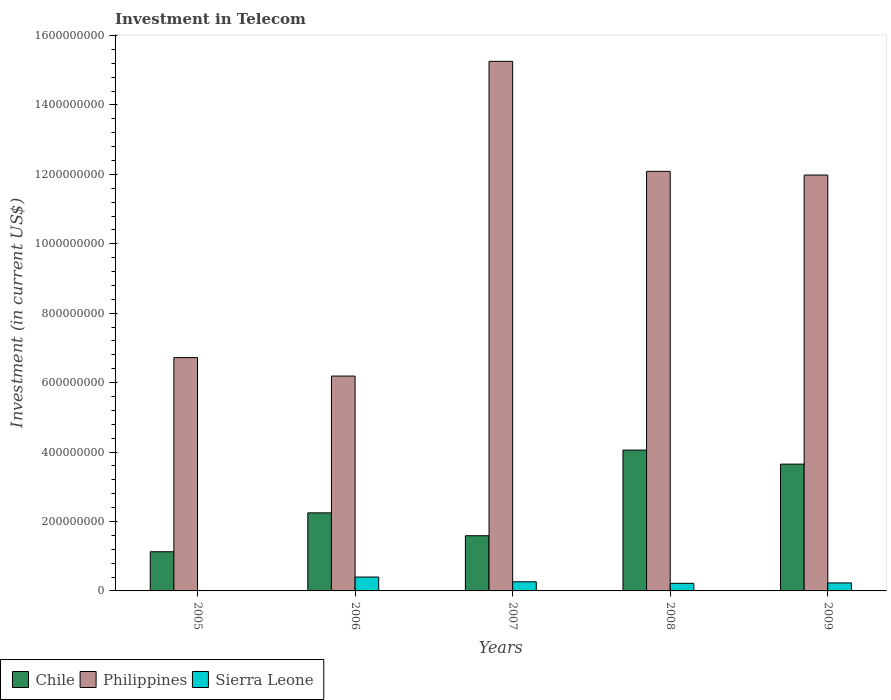Are the number of bars on each tick of the X-axis equal?
Your answer should be very brief. Yes. How many bars are there on the 5th tick from the right?
Offer a very short reply. 3. In how many cases, is the number of bars for a given year not equal to the number of legend labels?
Give a very brief answer. 0. What is the amount invested in telecom in Chile in 2006?
Make the answer very short. 2.25e+08. Across all years, what is the maximum amount invested in telecom in Sierra Leone?
Give a very brief answer. 4.00e+07. Across all years, what is the minimum amount invested in telecom in Chile?
Your answer should be very brief. 1.13e+08. In which year was the amount invested in telecom in Philippines maximum?
Make the answer very short. 2007. What is the total amount invested in telecom in Sierra Leone in the graph?
Offer a terse response. 1.11e+08. What is the difference between the amount invested in telecom in Sierra Leone in 2006 and that in 2007?
Provide a succinct answer. 1.37e+07. What is the difference between the amount invested in telecom in Sierra Leone in 2005 and the amount invested in telecom in Chile in 2006?
Your answer should be very brief. -2.25e+08. What is the average amount invested in telecom in Chile per year?
Your answer should be compact. 2.54e+08. In the year 2007, what is the difference between the amount invested in telecom in Philippines and amount invested in telecom in Chile?
Your answer should be compact. 1.37e+09. In how many years, is the amount invested in telecom in Chile greater than 1560000000 US$?
Ensure brevity in your answer.  0. What is the ratio of the amount invested in telecom in Chile in 2006 to that in 2008?
Offer a very short reply. 0.55. What is the difference between the highest and the second highest amount invested in telecom in Chile?
Your answer should be compact. 4.04e+07. What is the difference between the highest and the lowest amount invested in telecom in Sierra Leone?
Ensure brevity in your answer.  3.98e+07. In how many years, is the amount invested in telecom in Philippines greater than the average amount invested in telecom in Philippines taken over all years?
Your answer should be compact. 3. Is the sum of the amount invested in telecom in Chile in 2006 and 2007 greater than the maximum amount invested in telecom in Sierra Leone across all years?
Make the answer very short. Yes. What does the 3rd bar from the left in 2009 represents?
Your response must be concise. Sierra Leone. What does the 2nd bar from the right in 2007 represents?
Offer a terse response. Philippines. How many years are there in the graph?
Make the answer very short. 5. What is the difference between two consecutive major ticks on the Y-axis?
Your response must be concise. 2.00e+08. Are the values on the major ticks of Y-axis written in scientific E-notation?
Your response must be concise. No. Does the graph contain any zero values?
Keep it short and to the point. No. Does the graph contain grids?
Provide a short and direct response. No. Where does the legend appear in the graph?
Provide a succinct answer. Bottom left. How are the legend labels stacked?
Give a very brief answer. Horizontal. What is the title of the graph?
Your answer should be very brief. Investment in Telecom. Does "Zimbabwe" appear as one of the legend labels in the graph?
Make the answer very short. No. What is the label or title of the X-axis?
Make the answer very short. Years. What is the label or title of the Y-axis?
Keep it short and to the point. Investment (in current US$). What is the Investment (in current US$) in Chile in 2005?
Keep it short and to the point. 1.13e+08. What is the Investment (in current US$) in Philippines in 2005?
Offer a terse response. 6.72e+08. What is the Investment (in current US$) of Sierra Leone in 2005?
Offer a very short reply. 2.50e+05. What is the Investment (in current US$) of Chile in 2006?
Give a very brief answer. 2.25e+08. What is the Investment (in current US$) of Philippines in 2006?
Offer a very short reply. 6.19e+08. What is the Investment (in current US$) in Sierra Leone in 2006?
Keep it short and to the point. 4.00e+07. What is the Investment (in current US$) in Chile in 2007?
Offer a very short reply. 1.59e+08. What is the Investment (in current US$) of Philippines in 2007?
Keep it short and to the point. 1.53e+09. What is the Investment (in current US$) in Sierra Leone in 2007?
Your response must be concise. 2.63e+07. What is the Investment (in current US$) in Chile in 2008?
Your answer should be compact. 4.06e+08. What is the Investment (in current US$) of Philippines in 2008?
Your answer should be compact. 1.21e+09. What is the Investment (in current US$) in Sierra Leone in 2008?
Offer a very short reply. 2.19e+07. What is the Investment (in current US$) of Chile in 2009?
Keep it short and to the point. 3.65e+08. What is the Investment (in current US$) of Philippines in 2009?
Provide a succinct answer. 1.20e+09. What is the Investment (in current US$) in Sierra Leone in 2009?
Offer a very short reply. 2.30e+07. Across all years, what is the maximum Investment (in current US$) in Chile?
Ensure brevity in your answer.  4.06e+08. Across all years, what is the maximum Investment (in current US$) in Philippines?
Offer a very short reply. 1.53e+09. Across all years, what is the maximum Investment (in current US$) in Sierra Leone?
Offer a terse response. 4.00e+07. Across all years, what is the minimum Investment (in current US$) in Chile?
Ensure brevity in your answer.  1.13e+08. Across all years, what is the minimum Investment (in current US$) of Philippines?
Ensure brevity in your answer.  6.19e+08. What is the total Investment (in current US$) of Chile in the graph?
Give a very brief answer. 1.27e+09. What is the total Investment (in current US$) in Philippines in the graph?
Give a very brief answer. 5.22e+09. What is the total Investment (in current US$) of Sierra Leone in the graph?
Offer a terse response. 1.11e+08. What is the difference between the Investment (in current US$) of Chile in 2005 and that in 2006?
Your answer should be compact. -1.12e+08. What is the difference between the Investment (in current US$) in Philippines in 2005 and that in 2006?
Provide a short and direct response. 5.32e+07. What is the difference between the Investment (in current US$) in Sierra Leone in 2005 and that in 2006?
Make the answer very short. -3.98e+07. What is the difference between the Investment (in current US$) of Chile in 2005 and that in 2007?
Your answer should be compact. -4.61e+07. What is the difference between the Investment (in current US$) in Philippines in 2005 and that in 2007?
Your answer should be very brief. -8.53e+08. What is the difference between the Investment (in current US$) of Sierra Leone in 2005 and that in 2007?
Offer a very short reply. -2.60e+07. What is the difference between the Investment (in current US$) in Chile in 2005 and that in 2008?
Your answer should be very brief. -2.93e+08. What is the difference between the Investment (in current US$) of Philippines in 2005 and that in 2008?
Your response must be concise. -5.36e+08. What is the difference between the Investment (in current US$) of Sierra Leone in 2005 and that in 2008?
Offer a very short reply. -2.16e+07. What is the difference between the Investment (in current US$) of Chile in 2005 and that in 2009?
Provide a short and direct response. -2.52e+08. What is the difference between the Investment (in current US$) in Philippines in 2005 and that in 2009?
Make the answer very short. -5.26e+08. What is the difference between the Investment (in current US$) in Sierra Leone in 2005 and that in 2009?
Provide a succinct answer. -2.28e+07. What is the difference between the Investment (in current US$) of Chile in 2006 and that in 2007?
Your answer should be compact. 6.59e+07. What is the difference between the Investment (in current US$) in Philippines in 2006 and that in 2007?
Provide a succinct answer. -9.07e+08. What is the difference between the Investment (in current US$) in Sierra Leone in 2006 and that in 2007?
Your response must be concise. 1.37e+07. What is the difference between the Investment (in current US$) in Chile in 2006 and that in 2008?
Make the answer very short. -1.81e+08. What is the difference between the Investment (in current US$) in Philippines in 2006 and that in 2008?
Your response must be concise. -5.90e+08. What is the difference between the Investment (in current US$) of Sierra Leone in 2006 and that in 2008?
Provide a succinct answer. 1.81e+07. What is the difference between the Investment (in current US$) of Chile in 2006 and that in 2009?
Give a very brief answer. -1.40e+08. What is the difference between the Investment (in current US$) in Philippines in 2006 and that in 2009?
Your answer should be very brief. -5.79e+08. What is the difference between the Investment (in current US$) of Sierra Leone in 2006 and that in 2009?
Your answer should be very brief. 1.70e+07. What is the difference between the Investment (in current US$) in Chile in 2007 and that in 2008?
Keep it short and to the point. -2.47e+08. What is the difference between the Investment (in current US$) in Philippines in 2007 and that in 2008?
Keep it short and to the point. 3.17e+08. What is the difference between the Investment (in current US$) of Sierra Leone in 2007 and that in 2008?
Provide a succinct answer. 4.40e+06. What is the difference between the Investment (in current US$) in Chile in 2007 and that in 2009?
Keep it short and to the point. -2.06e+08. What is the difference between the Investment (in current US$) in Philippines in 2007 and that in 2009?
Ensure brevity in your answer.  3.28e+08. What is the difference between the Investment (in current US$) of Sierra Leone in 2007 and that in 2009?
Offer a terse response. 3.30e+06. What is the difference between the Investment (in current US$) in Chile in 2008 and that in 2009?
Ensure brevity in your answer.  4.04e+07. What is the difference between the Investment (in current US$) of Philippines in 2008 and that in 2009?
Offer a terse response. 1.06e+07. What is the difference between the Investment (in current US$) of Sierra Leone in 2008 and that in 2009?
Provide a succinct answer. -1.10e+06. What is the difference between the Investment (in current US$) in Chile in 2005 and the Investment (in current US$) in Philippines in 2006?
Offer a terse response. -5.06e+08. What is the difference between the Investment (in current US$) of Chile in 2005 and the Investment (in current US$) of Sierra Leone in 2006?
Provide a short and direct response. 7.29e+07. What is the difference between the Investment (in current US$) in Philippines in 2005 and the Investment (in current US$) in Sierra Leone in 2006?
Offer a very short reply. 6.32e+08. What is the difference between the Investment (in current US$) in Chile in 2005 and the Investment (in current US$) in Philippines in 2007?
Keep it short and to the point. -1.41e+09. What is the difference between the Investment (in current US$) of Chile in 2005 and the Investment (in current US$) of Sierra Leone in 2007?
Provide a succinct answer. 8.66e+07. What is the difference between the Investment (in current US$) of Philippines in 2005 and the Investment (in current US$) of Sierra Leone in 2007?
Offer a very short reply. 6.46e+08. What is the difference between the Investment (in current US$) of Chile in 2005 and the Investment (in current US$) of Philippines in 2008?
Your response must be concise. -1.10e+09. What is the difference between the Investment (in current US$) of Chile in 2005 and the Investment (in current US$) of Sierra Leone in 2008?
Provide a succinct answer. 9.10e+07. What is the difference between the Investment (in current US$) of Philippines in 2005 and the Investment (in current US$) of Sierra Leone in 2008?
Your answer should be very brief. 6.50e+08. What is the difference between the Investment (in current US$) of Chile in 2005 and the Investment (in current US$) of Philippines in 2009?
Offer a very short reply. -1.09e+09. What is the difference between the Investment (in current US$) in Chile in 2005 and the Investment (in current US$) in Sierra Leone in 2009?
Your response must be concise. 8.99e+07. What is the difference between the Investment (in current US$) of Philippines in 2005 and the Investment (in current US$) of Sierra Leone in 2009?
Keep it short and to the point. 6.49e+08. What is the difference between the Investment (in current US$) in Chile in 2006 and the Investment (in current US$) in Philippines in 2007?
Offer a terse response. -1.30e+09. What is the difference between the Investment (in current US$) in Chile in 2006 and the Investment (in current US$) in Sierra Leone in 2007?
Provide a short and direct response. 1.99e+08. What is the difference between the Investment (in current US$) of Philippines in 2006 and the Investment (in current US$) of Sierra Leone in 2007?
Provide a short and direct response. 5.93e+08. What is the difference between the Investment (in current US$) in Chile in 2006 and the Investment (in current US$) in Philippines in 2008?
Provide a succinct answer. -9.84e+08. What is the difference between the Investment (in current US$) of Chile in 2006 and the Investment (in current US$) of Sierra Leone in 2008?
Your answer should be very brief. 2.03e+08. What is the difference between the Investment (in current US$) of Philippines in 2006 and the Investment (in current US$) of Sierra Leone in 2008?
Make the answer very short. 5.97e+08. What is the difference between the Investment (in current US$) in Chile in 2006 and the Investment (in current US$) in Philippines in 2009?
Make the answer very short. -9.73e+08. What is the difference between the Investment (in current US$) of Chile in 2006 and the Investment (in current US$) of Sierra Leone in 2009?
Provide a short and direct response. 2.02e+08. What is the difference between the Investment (in current US$) in Philippines in 2006 and the Investment (in current US$) in Sierra Leone in 2009?
Keep it short and to the point. 5.96e+08. What is the difference between the Investment (in current US$) in Chile in 2007 and the Investment (in current US$) in Philippines in 2008?
Offer a terse response. -1.05e+09. What is the difference between the Investment (in current US$) in Chile in 2007 and the Investment (in current US$) in Sierra Leone in 2008?
Your answer should be very brief. 1.37e+08. What is the difference between the Investment (in current US$) of Philippines in 2007 and the Investment (in current US$) of Sierra Leone in 2008?
Ensure brevity in your answer.  1.50e+09. What is the difference between the Investment (in current US$) of Chile in 2007 and the Investment (in current US$) of Philippines in 2009?
Make the answer very short. -1.04e+09. What is the difference between the Investment (in current US$) in Chile in 2007 and the Investment (in current US$) in Sierra Leone in 2009?
Ensure brevity in your answer.  1.36e+08. What is the difference between the Investment (in current US$) in Philippines in 2007 and the Investment (in current US$) in Sierra Leone in 2009?
Make the answer very short. 1.50e+09. What is the difference between the Investment (in current US$) of Chile in 2008 and the Investment (in current US$) of Philippines in 2009?
Provide a short and direct response. -7.92e+08. What is the difference between the Investment (in current US$) of Chile in 2008 and the Investment (in current US$) of Sierra Leone in 2009?
Give a very brief answer. 3.83e+08. What is the difference between the Investment (in current US$) of Philippines in 2008 and the Investment (in current US$) of Sierra Leone in 2009?
Provide a short and direct response. 1.19e+09. What is the average Investment (in current US$) of Chile per year?
Your answer should be very brief. 2.54e+08. What is the average Investment (in current US$) in Philippines per year?
Provide a succinct answer. 1.04e+09. What is the average Investment (in current US$) of Sierra Leone per year?
Provide a short and direct response. 2.23e+07. In the year 2005, what is the difference between the Investment (in current US$) of Chile and Investment (in current US$) of Philippines?
Offer a very short reply. -5.59e+08. In the year 2005, what is the difference between the Investment (in current US$) of Chile and Investment (in current US$) of Sierra Leone?
Provide a short and direct response. 1.13e+08. In the year 2005, what is the difference between the Investment (in current US$) in Philippines and Investment (in current US$) in Sierra Leone?
Provide a short and direct response. 6.72e+08. In the year 2006, what is the difference between the Investment (in current US$) in Chile and Investment (in current US$) in Philippines?
Provide a short and direct response. -3.94e+08. In the year 2006, what is the difference between the Investment (in current US$) of Chile and Investment (in current US$) of Sierra Leone?
Give a very brief answer. 1.85e+08. In the year 2006, what is the difference between the Investment (in current US$) in Philippines and Investment (in current US$) in Sierra Leone?
Ensure brevity in your answer.  5.79e+08. In the year 2007, what is the difference between the Investment (in current US$) in Chile and Investment (in current US$) in Philippines?
Offer a terse response. -1.37e+09. In the year 2007, what is the difference between the Investment (in current US$) of Chile and Investment (in current US$) of Sierra Leone?
Give a very brief answer. 1.33e+08. In the year 2007, what is the difference between the Investment (in current US$) of Philippines and Investment (in current US$) of Sierra Leone?
Make the answer very short. 1.50e+09. In the year 2008, what is the difference between the Investment (in current US$) of Chile and Investment (in current US$) of Philippines?
Your answer should be very brief. -8.03e+08. In the year 2008, what is the difference between the Investment (in current US$) in Chile and Investment (in current US$) in Sierra Leone?
Your response must be concise. 3.84e+08. In the year 2008, what is the difference between the Investment (in current US$) in Philippines and Investment (in current US$) in Sierra Leone?
Your answer should be compact. 1.19e+09. In the year 2009, what is the difference between the Investment (in current US$) of Chile and Investment (in current US$) of Philippines?
Provide a short and direct response. -8.33e+08. In the year 2009, what is the difference between the Investment (in current US$) in Chile and Investment (in current US$) in Sierra Leone?
Offer a terse response. 3.42e+08. In the year 2009, what is the difference between the Investment (in current US$) in Philippines and Investment (in current US$) in Sierra Leone?
Your answer should be very brief. 1.18e+09. What is the ratio of the Investment (in current US$) of Chile in 2005 to that in 2006?
Provide a short and direct response. 0.5. What is the ratio of the Investment (in current US$) of Philippines in 2005 to that in 2006?
Provide a short and direct response. 1.09. What is the ratio of the Investment (in current US$) in Sierra Leone in 2005 to that in 2006?
Ensure brevity in your answer.  0.01. What is the ratio of the Investment (in current US$) in Chile in 2005 to that in 2007?
Offer a very short reply. 0.71. What is the ratio of the Investment (in current US$) of Philippines in 2005 to that in 2007?
Give a very brief answer. 0.44. What is the ratio of the Investment (in current US$) of Sierra Leone in 2005 to that in 2007?
Your answer should be very brief. 0.01. What is the ratio of the Investment (in current US$) of Chile in 2005 to that in 2008?
Offer a terse response. 0.28. What is the ratio of the Investment (in current US$) in Philippines in 2005 to that in 2008?
Give a very brief answer. 0.56. What is the ratio of the Investment (in current US$) of Sierra Leone in 2005 to that in 2008?
Your answer should be compact. 0.01. What is the ratio of the Investment (in current US$) of Chile in 2005 to that in 2009?
Give a very brief answer. 0.31. What is the ratio of the Investment (in current US$) in Philippines in 2005 to that in 2009?
Your answer should be compact. 0.56. What is the ratio of the Investment (in current US$) of Sierra Leone in 2005 to that in 2009?
Your answer should be very brief. 0.01. What is the ratio of the Investment (in current US$) of Chile in 2006 to that in 2007?
Provide a succinct answer. 1.41. What is the ratio of the Investment (in current US$) of Philippines in 2006 to that in 2007?
Keep it short and to the point. 0.41. What is the ratio of the Investment (in current US$) of Sierra Leone in 2006 to that in 2007?
Provide a short and direct response. 1.52. What is the ratio of the Investment (in current US$) of Chile in 2006 to that in 2008?
Give a very brief answer. 0.55. What is the ratio of the Investment (in current US$) in Philippines in 2006 to that in 2008?
Provide a short and direct response. 0.51. What is the ratio of the Investment (in current US$) of Sierra Leone in 2006 to that in 2008?
Offer a very short reply. 1.83. What is the ratio of the Investment (in current US$) in Chile in 2006 to that in 2009?
Provide a short and direct response. 0.62. What is the ratio of the Investment (in current US$) in Philippines in 2006 to that in 2009?
Offer a very short reply. 0.52. What is the ratio of the Investment (in current US$) of Sierra Leone in 2006 to that in 2009?
Provide a succinct answer. 1.74. What is the ratio of the Investment (in current US$) in Chile in 2007 to that in 2008?
Give a very brief answer. 0.39. What is the ratio of the Investment (in current US$) in Philippines in 2007 to that in 2008?
Make the answer very short. 1.26. What is the ratio of the Investment (in current US$) in Sierra Leone in 2007 to that in 2008?
Offer a terse response. 1.2. What is the ratio of the Investment (in current US$) of Chile in 2007 to that in 2009?
Provide a succinct answer. 0.44. What is the ratio of the Investment (in current US$) in Philippines in 2007 to that in 2009?
Give a very brief answer. 1.27. What is the ratio of the Investment (in current US$) of Sierra Leone in 2007 to that in 2009?
Offer a very short reply. 1.14. What is the ratio of the Investment (in current US$) of Chile in 2008 to that in 2009?
Provide a succinct answer. 1.11. What is the ratio of the Investment (in current US$) in Philippines in 2008 to that in 2009?
Provide a short and direct response. 1.01. What is the ratio of the Investment (in current US$) in Sierra Leone in 2008 to that in 2009?
Make the answer very short. 0.95. What is the difference between the highest and the second highest Investment (in current US$) of Chile?
Offer a very short reply. 4.04e+07. What is the difference between the highest and the second highest Investment (in current US$) of Philippines?
Your answer should be compact. 3.17e+08. What is the difference between the highest and the second highest Investment (in current US$) of Sierra Leone?
Provide a short and direct response. 1.37e+07. What is the difference between the highest and the lowest Investment (in current US$) in Chile?
Give a very brief answer. 2.93e+08. What is the difference between the highest and the lowest Investment (in current US$) of Philippines?
Offer a very short reply. 9.07e+08. What is the difference between the highest and the lowest Investment (in current US$) of Sierra Leone?
Make the answer very short. 3.98e+07. 